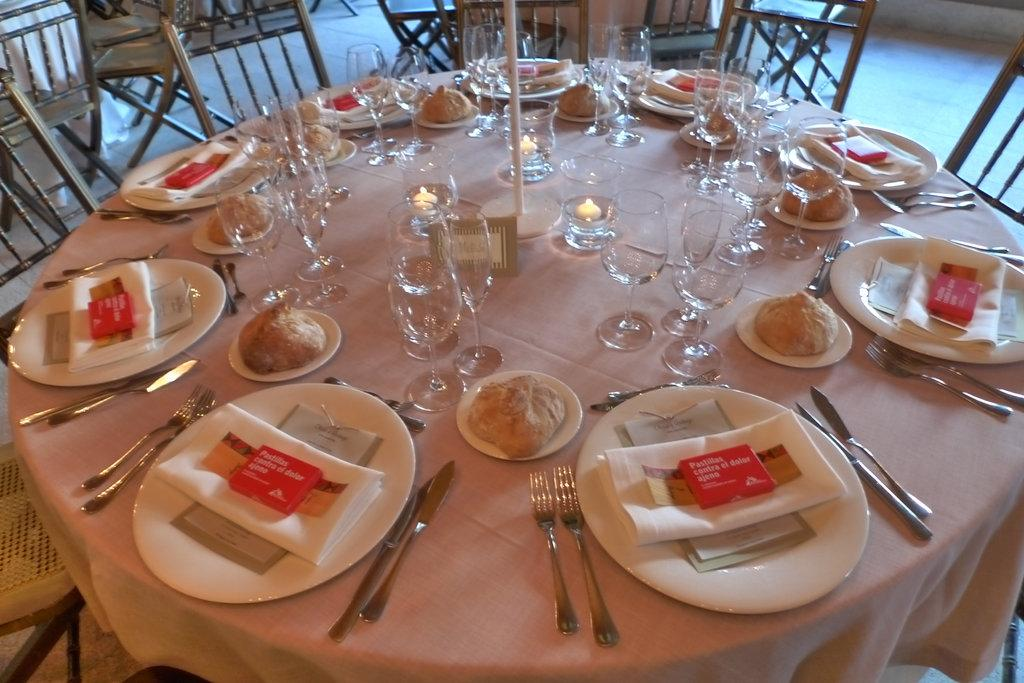What type of tableware can be seen in the image? Plates, forks, spoons, and glasses are visible in the image. What can be used for cleaning or wiping in the image? Tissues are present in the image for cleaning or wiping. What is on the table in the image? There is a board on the table in the image. What is the color of the tablecloth in the image? The table is covered with a peach-colored cloth. What type of seating is present in the image? There are chairs in the image. Can you see any cobwebs in the image? There is no mention of cobwebs in the image, so it cannot be determined if any are present. 